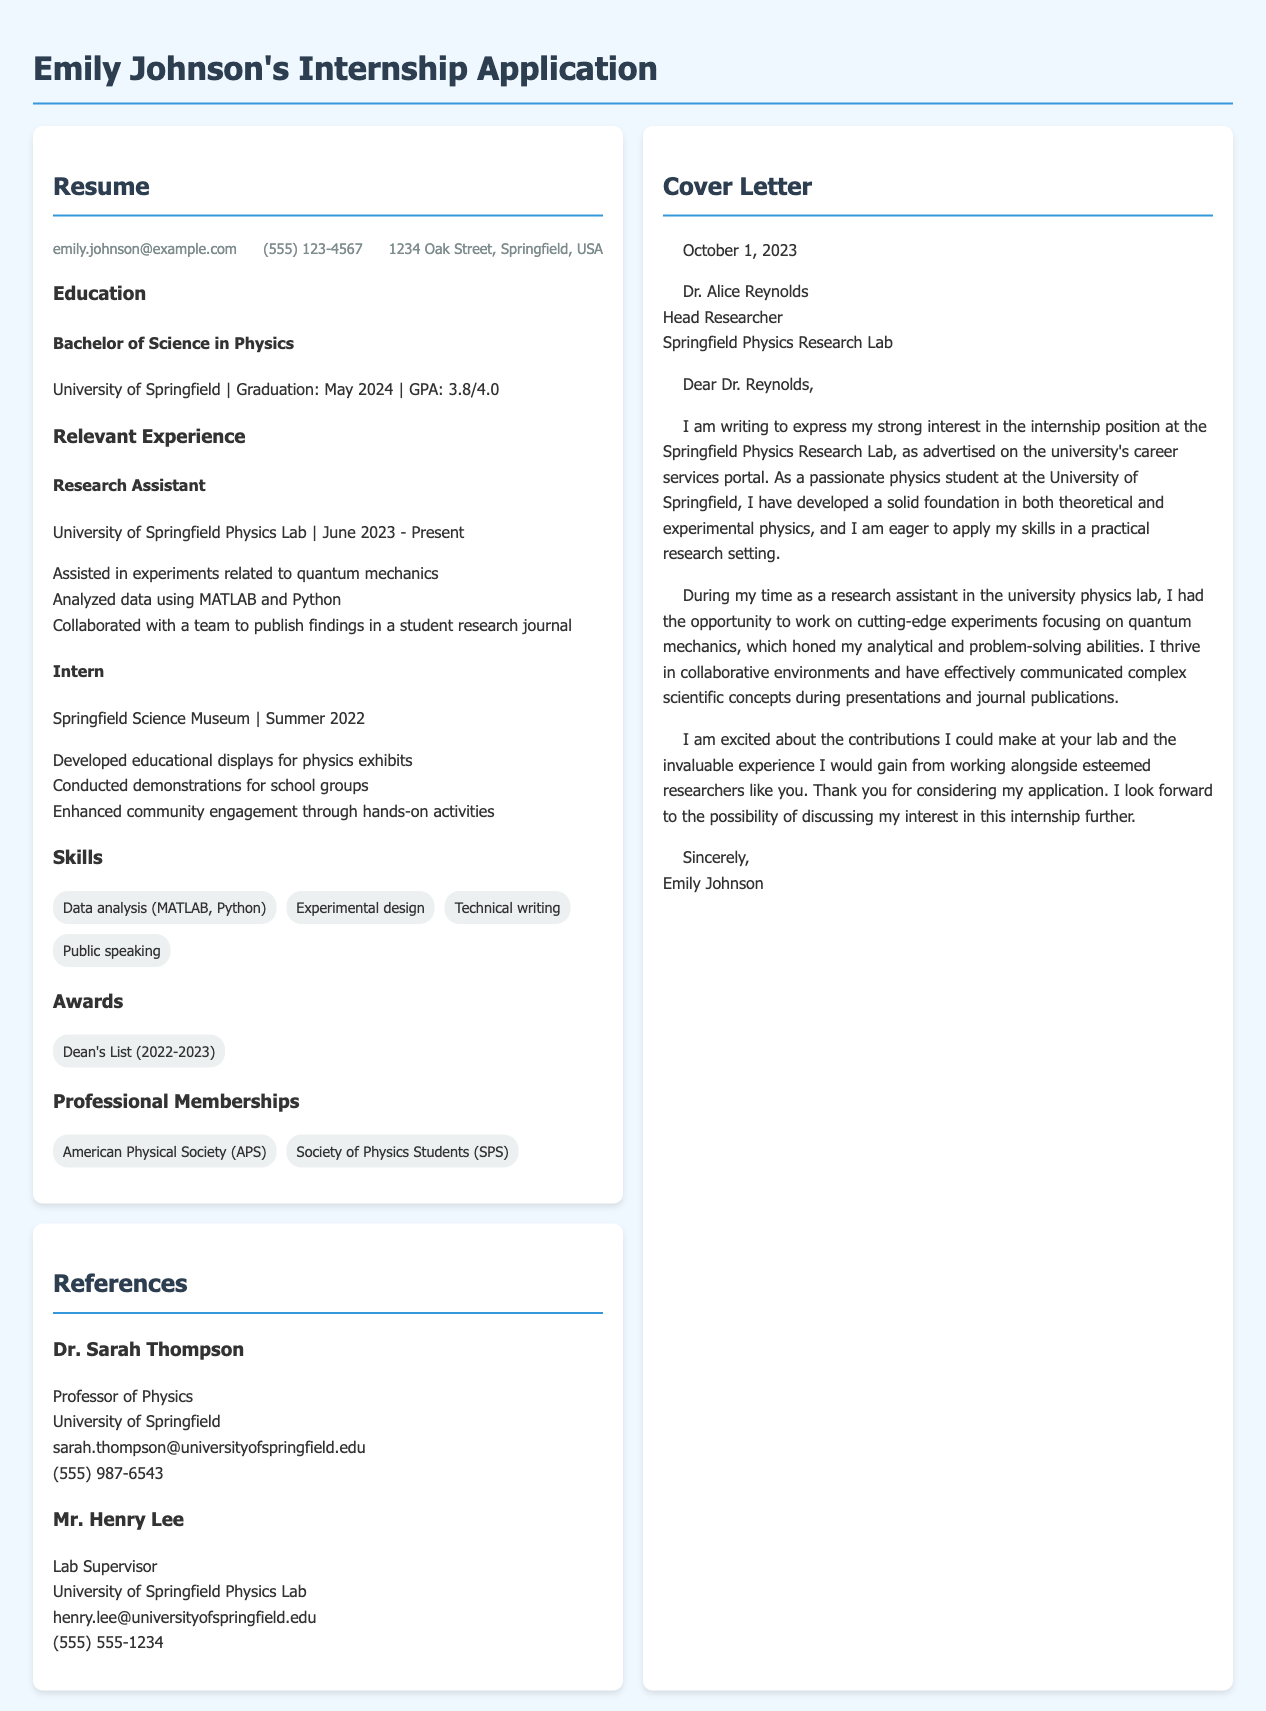What is Emily Johnson's email address? The document specifies the contact information of Emily Johnson, including her email address.
Answer: emily.johnson@example.com What is the GPA of Emily Johnson? The document mentions her educational background, including the GPA from her degree program.
Answer: 3.8/4.0 What position is Emily applying for? The cover letter explicitly states the internship position she is interested in at the research lab.
Answer: internship position Who is the reference labeled "Lab Supervisor"? The references section includes names and titles of individuals who can provide recommendations for Emily.
Answer: Mr. Henry Lee In which research area did Emily assist as a research assistant? The resume lists the specific experiments Emily participated in, indicating her area of focus.
Answer: quantum mechanics What year is Emily expected to graduate? The document provides information about her education, including her expected graduation date.
Answer: May 2024 What type of organization is the American Physical Society? This question requires reasoning about the memberships listed, which indicates professional affiliations.
Answer: Professional society How many awards are mentioned in the resume? The awards section was checked for the number of recognitions that Emily has received.
Answer: 1 What skills does Emily list related to data analysis? The skills section includes specific tools Emily is proficient in that relate to data analysis.
Answer: MATLAB, Python 